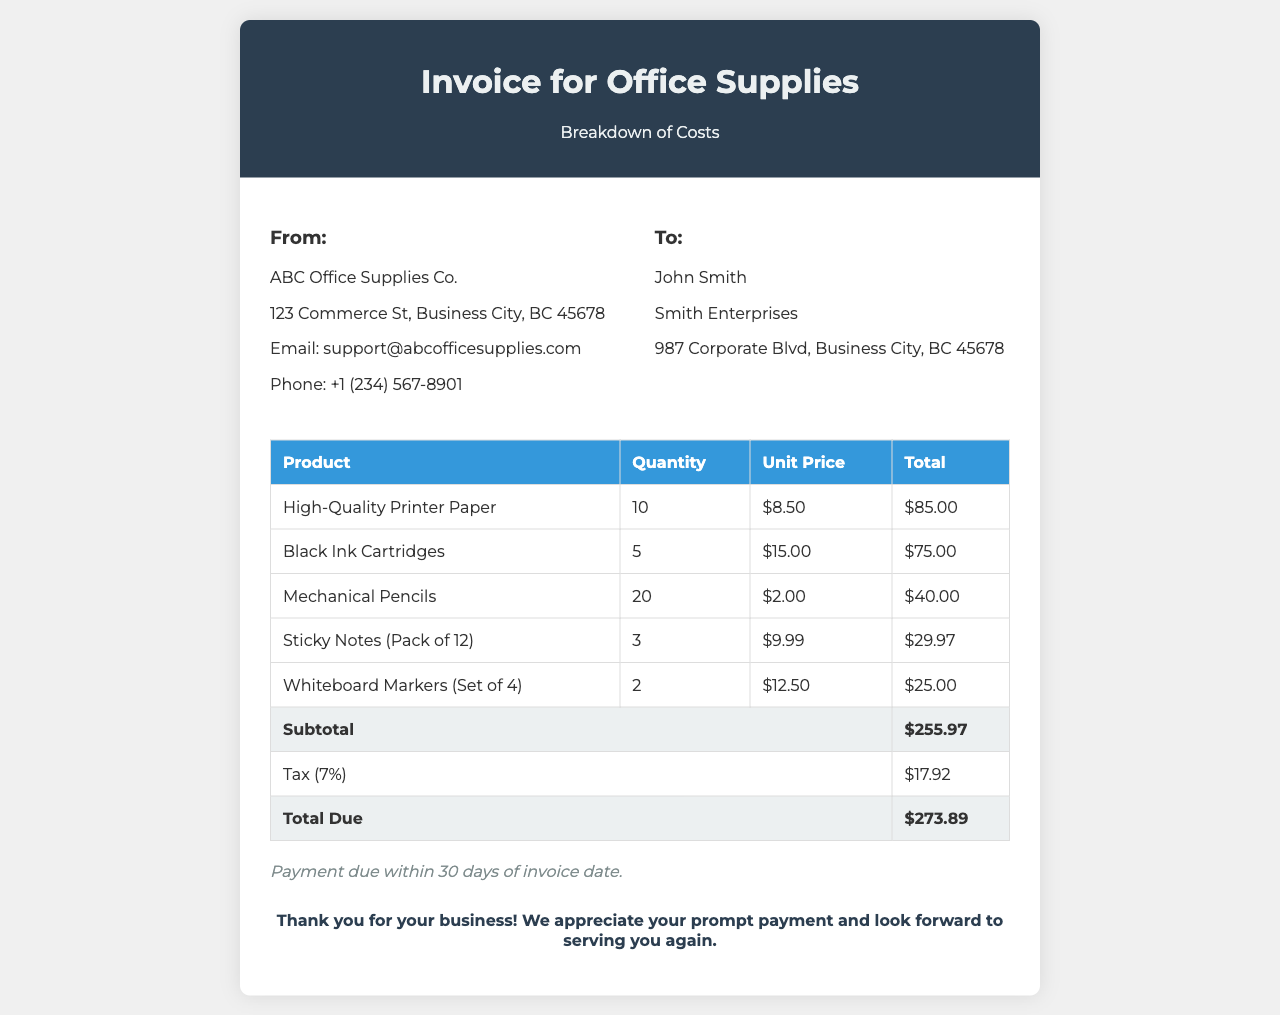What is the subtotal? The subtotal is the sum of all product totals before tax in the invoice, which is $255.97.
Answer: $255.97 Who is the client? The client is the individual or business receiving the invoice, which is John Smith.
Answer: John Smith What is the total due amount? The total due is the final amount to be paid after including tax, which is $273.89.
Answer: $273.89 How many mechanical pencils were purchased? The quantity of mechanical pencils listed in the invoice is 20.
Answer: 20 What is the tax rate applied to the invoice? The tax rate mentioned in the document is 7%.
Answer: 7% Who is the supplier of the office supplies? The supplier is the company issuing the invoice, which is ABC Office Supplies Co.
Answer: ABC Office Supplies Co What is included in the payment terms? The payment terms specify when the payment is due, which states payment is due within 30 days of invoice date.
Answer: 30 days What is the total quantity of sticky notes purchased? The quantity of sticky notes listed in the invoice is 3 packs.
Answer: 3 What is the unit price of black ink cartridges? The unit price for black ink cartridges is stated as $15.00.
Answer: $15.00 